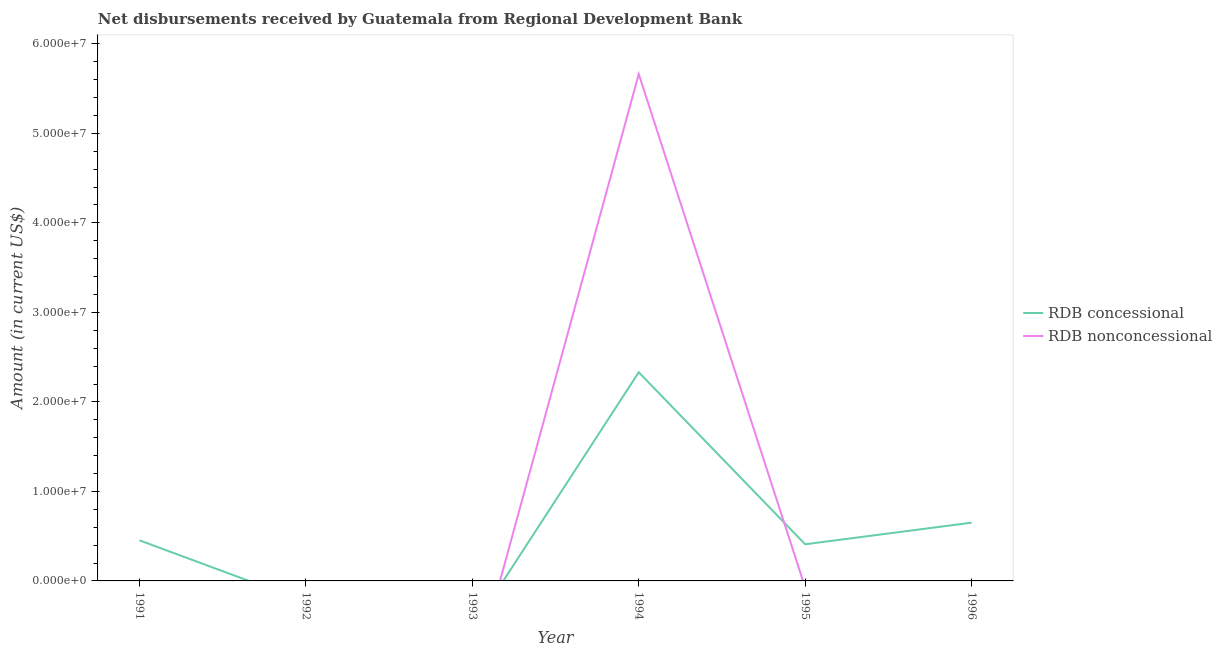What is the net concessional disbursements from rdb in 1994?
Your answer should be very brief. 2.33e+07. Across all years, what is the maximum net concessional disbursements from rdb?
Keep it short and to the point. 2.33e+07. What is the total net concessional disbursements from rdb in the graph?
Keep it short and to the point. 3.84e+07. What is the difference between the net concessional disbursements from rdb in 1995 and that in 1996?
Provide a succinct answer. -2.41e+06. What is the average net non concessional disbursements from rdb per year?
Provide a succinct answer. 9.44e+06. In the year 1994, what is the difference between the net non concessional disbursements from rdb and net concessional disbursements from rdb?
Offer a very short reply. 3.33e+07. In how many years, is the net concessional disbursements from rdb greater than 52000000 US$?
Give a very brief answer. 0. What is the ratio of the net concessional disbursements from rdb in 1994 to that in 1996?
Make the answer very short. 3.58. What is the difference between the highest and the second highest net concessional disbursements from rdb?
Make the answer very short. 1.68e+07. What is the difference between the highest and the lowest net non concessional disbursements from rdb?
Offer a terse response. 5.66e+07. Does the net non concessional disbursements from rdb monotonically increase over the years?
Provide a succinct answer. No. How many lines are there?
Keep it short and to the point. 2. How many years are there in the graph?
Your answer should be very brief. 6. What is the difference between two consecutive major ticks on the Y-axis?
Your answer should be very brief. 1.00e+07. Does the graph contain any zero values?
Give a very brief answer. Yes. How many legend labels are there?
Provide a short and direct response. 2. What is the title of the graph?
Your response must be concise. Net disbursements received by Guatemala from Regional Development Bank. Does "Under-5(female)" appear as one of the legend labels in the graph?
Ensure brevity in your answer.  No. What is the Amount (in current US$) in RDB concessional in 1991?
Keep it short and to the point. 4.53e+06. What is the Amount (in current US$) in RDB nonconcessional in 1991?
Your response must be concise. 0. What is the Amount (in current US$) of RDB concessional in 1993?
Ensure brevity in your answer.  0. What is the Amount (in current US$) of RDB concessional in 1994?
Provide a short and direct response. 2.33e+07. What is the Amount (in current US$) of RDB nonconcessional in 1994?
Your response must be concise. 5.66e+07. What is the Amount (in current US$) of RDB concessional in 1995?
Your answer should be very brief. 4.09e+06. What is the Amount (in current US$) of RDB concessional in 1996?
Offer a terse response. 6.51e+06. What is the Amount (in current US$) of RDB nonconcessional in 1996?
Give a very brief answer. 0. Across all years, what is the maximum Amount (in current US$) in RDB concessional?
Offer a very short reply. 2.33e+07. Across all years, what is the maximum Amount (in current US$) in RDB nonconcessional?
Your answer should be very brief. 5.66e+07. What is the total Amount (in current US$) of RDB concessional in the graph?
Give a very brief answer. 3.84e+07. What is the total Amount (in current US$) in RDB nonconcessional in the graph?
Keep it short and to the point. 5.66e+07. What is the difference between the Amount (in current US$) of RDB concessional in 1991 and that in 1994?
Keep it short and to the point. -1.88e+07. What is the difference between the Amount (in current US$) of RDB concessional in 1991 and that in 1995?
Offer a very short reply. 4.39e+05. What is the difference between the Amount (in current US$) of RDB concessional in 1991 and that in 1996?
Your answer should be very brief. -1.97e+06. What is the difference between the Amount (in current US$) of RDB concessional in 1994 and that in 1995?
Give a very brief answer. 1.92e+07. What is the difference between the Amount (in current US$) of RDB concessional in 1994 and that in 1996?
Provide a succinct answer. 1.68e+07. What is the difference between the Amount (in current US$) in RDB concessional in 1995 and that in 1996?
Make the answer very short. -2.41e+06. What is the difference between the Amount (in current US$) in RDB concessional in 1991 and the Amount (in current US$) in RDB nonconcessional in 1994?
Make the answer very short. -5.21e+07. What is the average Amount (in current US$) of RDB concessional per year?
Ensure brevity in your answer.  6.41e+06. What is the average Amount (in current US$) of RDB nonconcessional per year?
Keep it short and to the point. 9.44e+06. In the year 1994, what is the difference between the Amount (in current US$) of RDB concessional and Amount (in current US$) of RDB nonconcessional?
Give a very brief answer. -3.33e+07. What is the ratio of the Amount (in current US$) of RDB concessional in 1991 to that in 1994?
Provide a succinct answer. 0.19. What is the ratio of the Amount (in current US$) in RDB concessional in 1991 to that in 1995?
Keep it short and to the point. 1.11. What is the ratio of the Amount (in current US$) of RDB concessional in 1991 to that in 1996?
Give a very brief answer. 0.7. What is the ratio of the Amount (in current US$) in RDB concessional in 1994 to that in 1995?
Your response must be concise. 5.69. What is the ratio of the Amount (in current US$) of RDB concessional in 1994 to that in 1996?
Your answer should be very brief. 3.58. What is the ratio of the Amount (in current US$) in RDB concessional in 1995 to that in 1996?
Your answer should be compact. 0.63. What is the difference between the highest and the second highest Amount (in current US$) in RDB concessional?
Ensure brevity in your answer.  1.68e+07. What is the difference between the highest and the lowest Amount (in current US$) in RDB concessional?
Give a very brief answer. 2.33e+07. What is the difference between the highest and the lowest Amount (in current US$) in RDB nonconcessional?
Your response must be concise. 5.66e+07. 